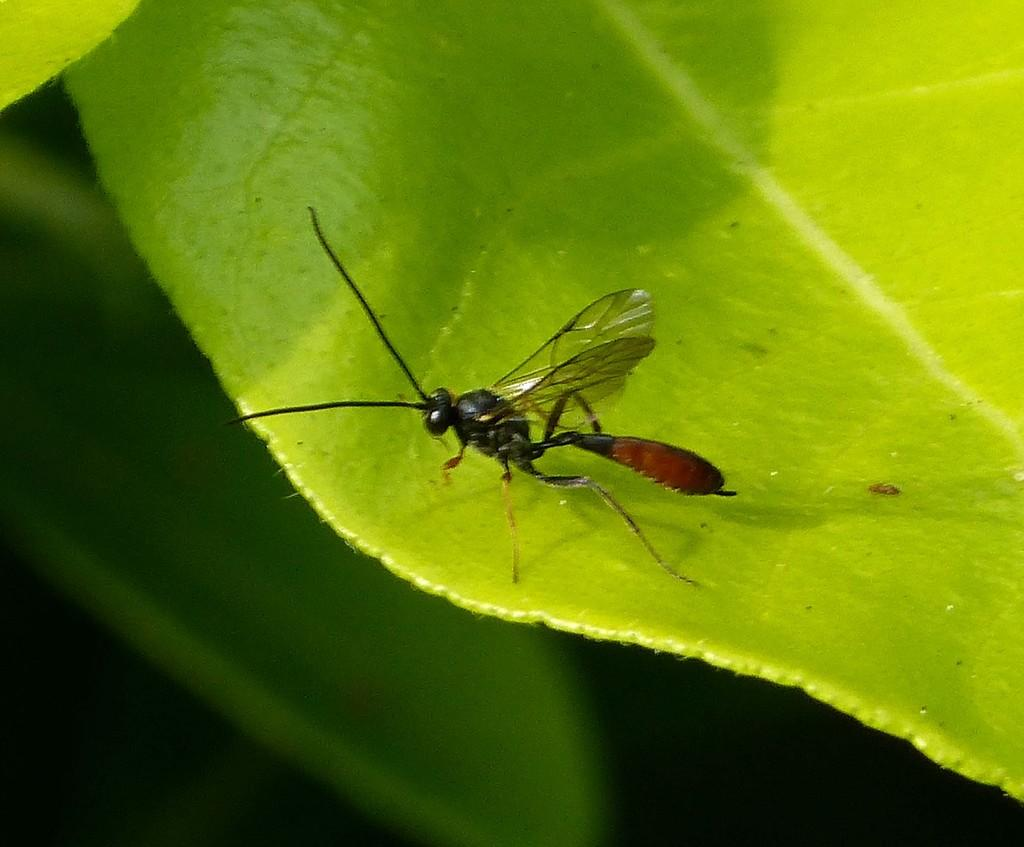What is on the leaf in the image? There is an insect on a leaf in the image. How would you describe the lighting at the bottom of the image? The bottom of the image is dark. What color is the leaf in the image? The leaf in the image is green. How many women are washing lettuce in the image? There are no women or lettuce present in the image. 